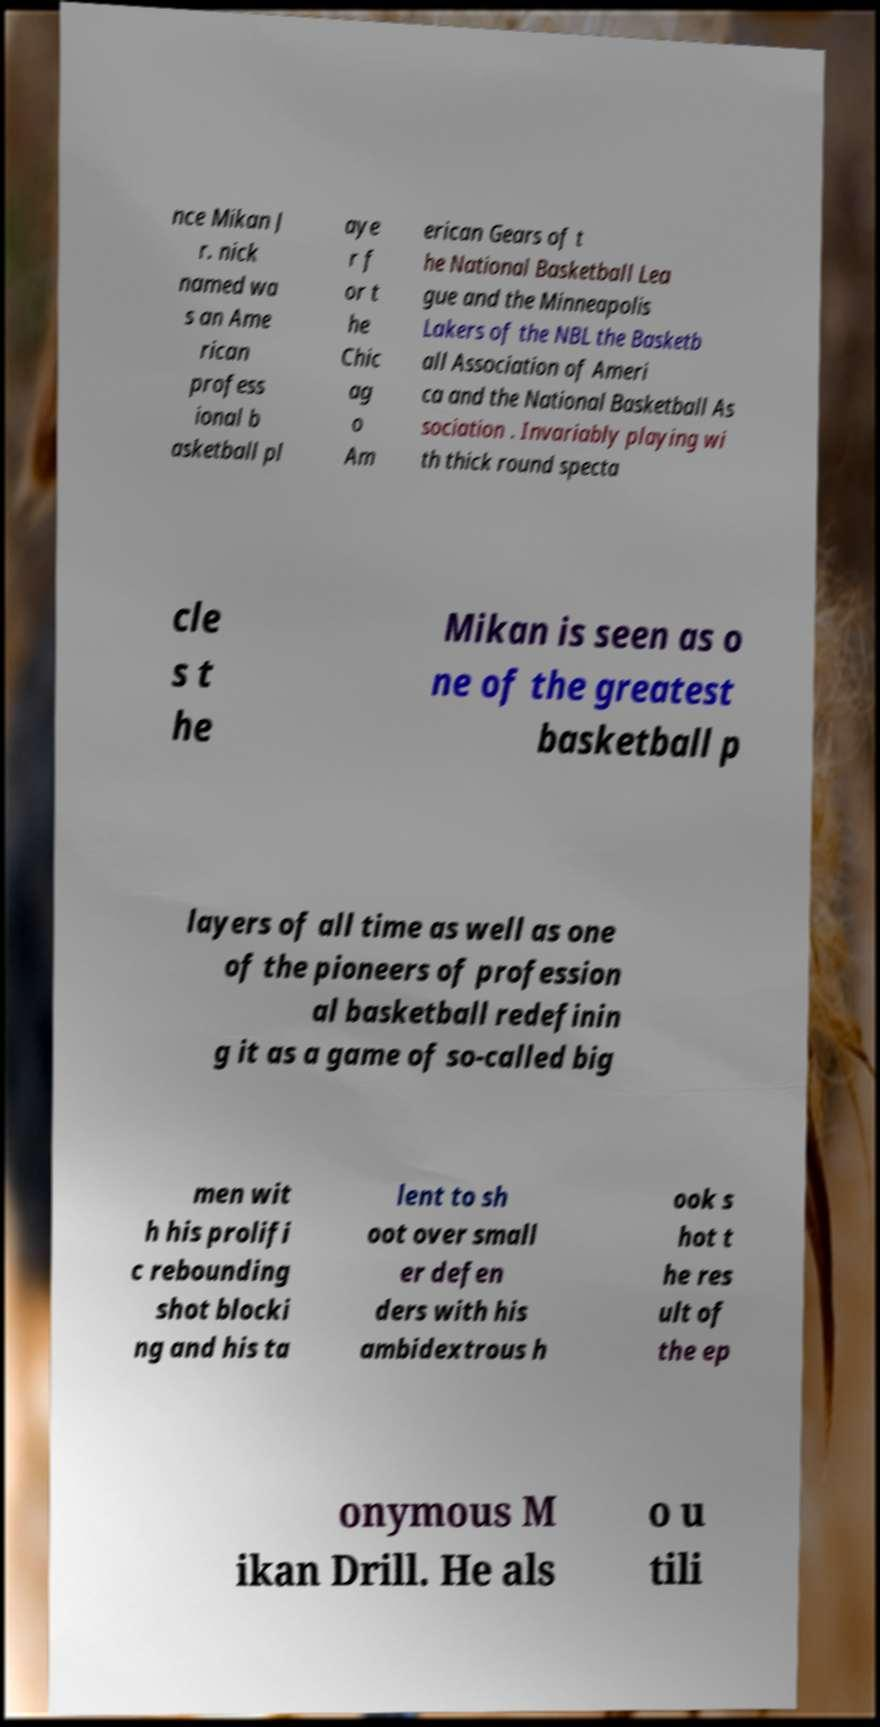Please identify and transcribe the text found in this image. nce Mikan J r. nick named wa s an Ame rican profess ional b asketball pl aye r f or t he Chic ag o Am erican Gears of t he National Basketball Lea gue and the Minneapolis Lakers of the NBL the Basketb all Association of Ameri ca and the National Basketball As sociation . Invariably playing wi th thick round specta cle s t he Mikan is seen as o ne of the greatest basketball p layers of all time as well as one of the pioneers of profession al basketball redefinin g it as a game of so-called big men wit h his prolifi c rebounding shot blocki ng and his ta lent to sh oot over small er defen ders with his ambidextrous h ook s hot t he res ult of the ep onymous M ikan Drill. He als o u tili 